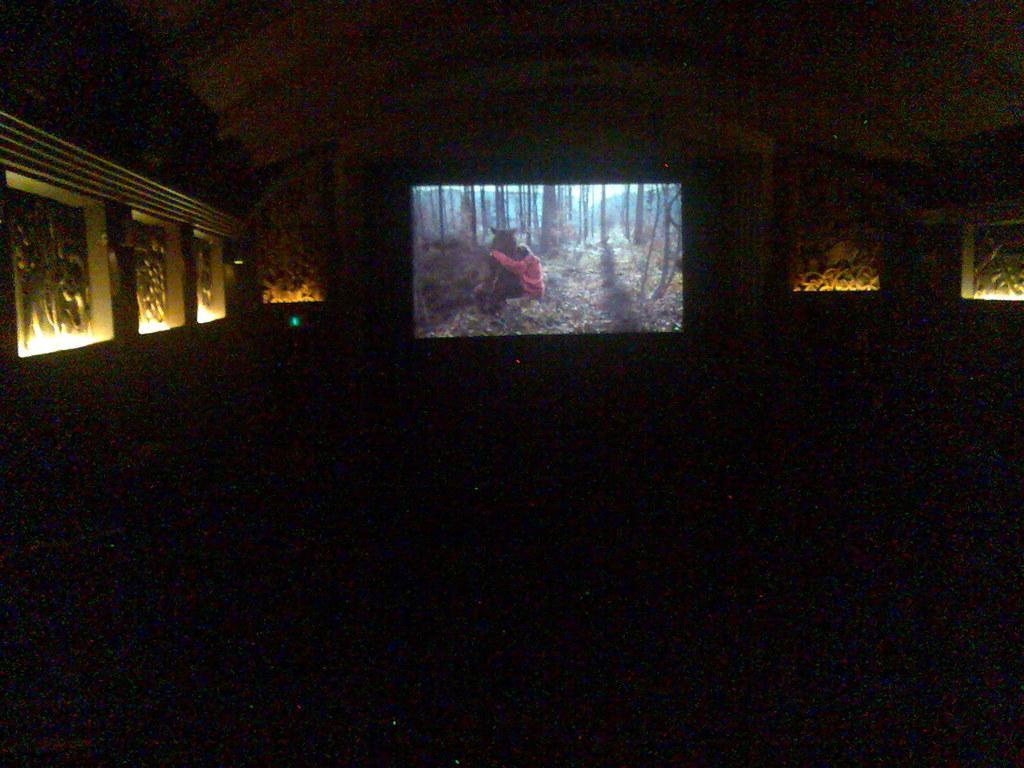How would you summarize this image in a sentence or two? In the picture I can see an image on the screen and there is a designed wall and few lights on either sides of it. 